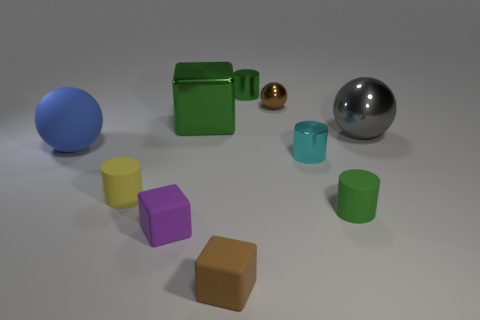Subtract all green metal cylinders. How many cylinders are left? 3 Subtract 3 cubes. How many cubes are left? 0 Subtract all yellow cylinders. How many cylinders are left? 3 Subtract all cylinders. How many objects are left? 6 Subtract all small cylinders. Subtract all purple rubber things. How many objects are left? 5 Add 4 big green blocks. How many big green blocks are left? 5 Add 9 tiny green metal things. How many tiny green metal things exist? 10 Subtract 0 red cylinders. How many objects are left? 10 Subtract all red cubes. Subtract all brown cylinders. How many cubes are left? 3 Subtract all green cubes. How many purple balls are left? 0 